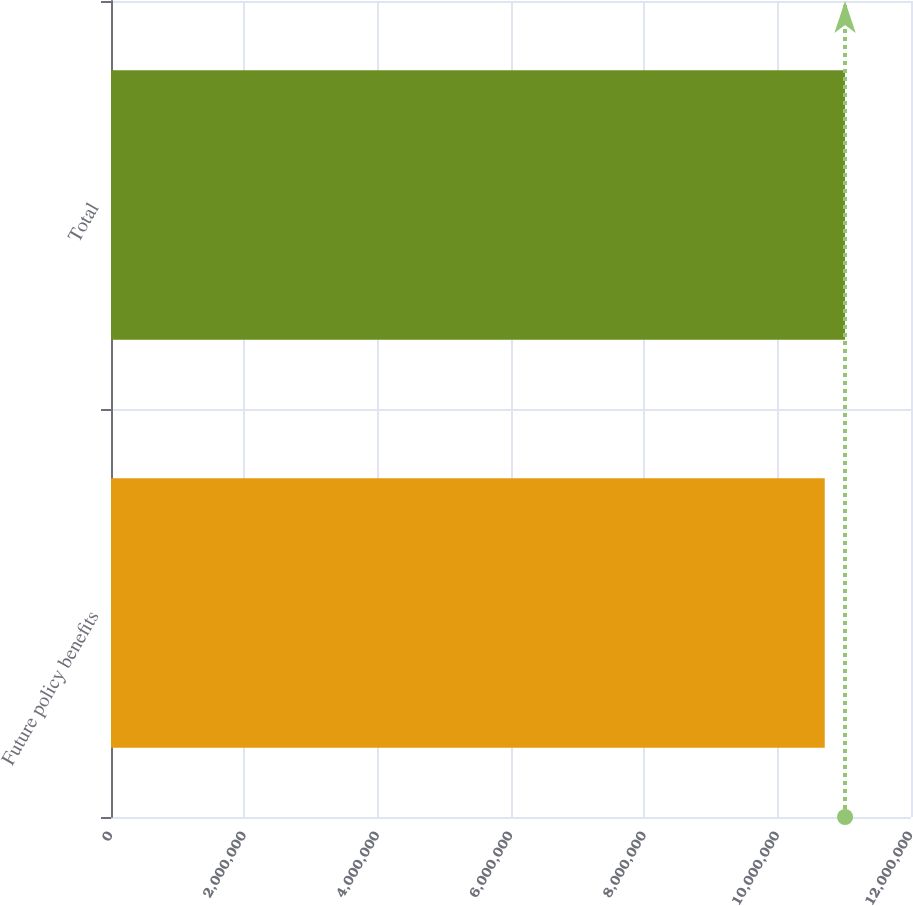Convert chart to OTSL. <chart><loc_0><loc_0><loc_500><loc_500><bar_chart><fcel>Future policy benefits<fcel>Total<nl><fcel>1.07062e+07<fcel>1.10108e+07<nl></chart> 